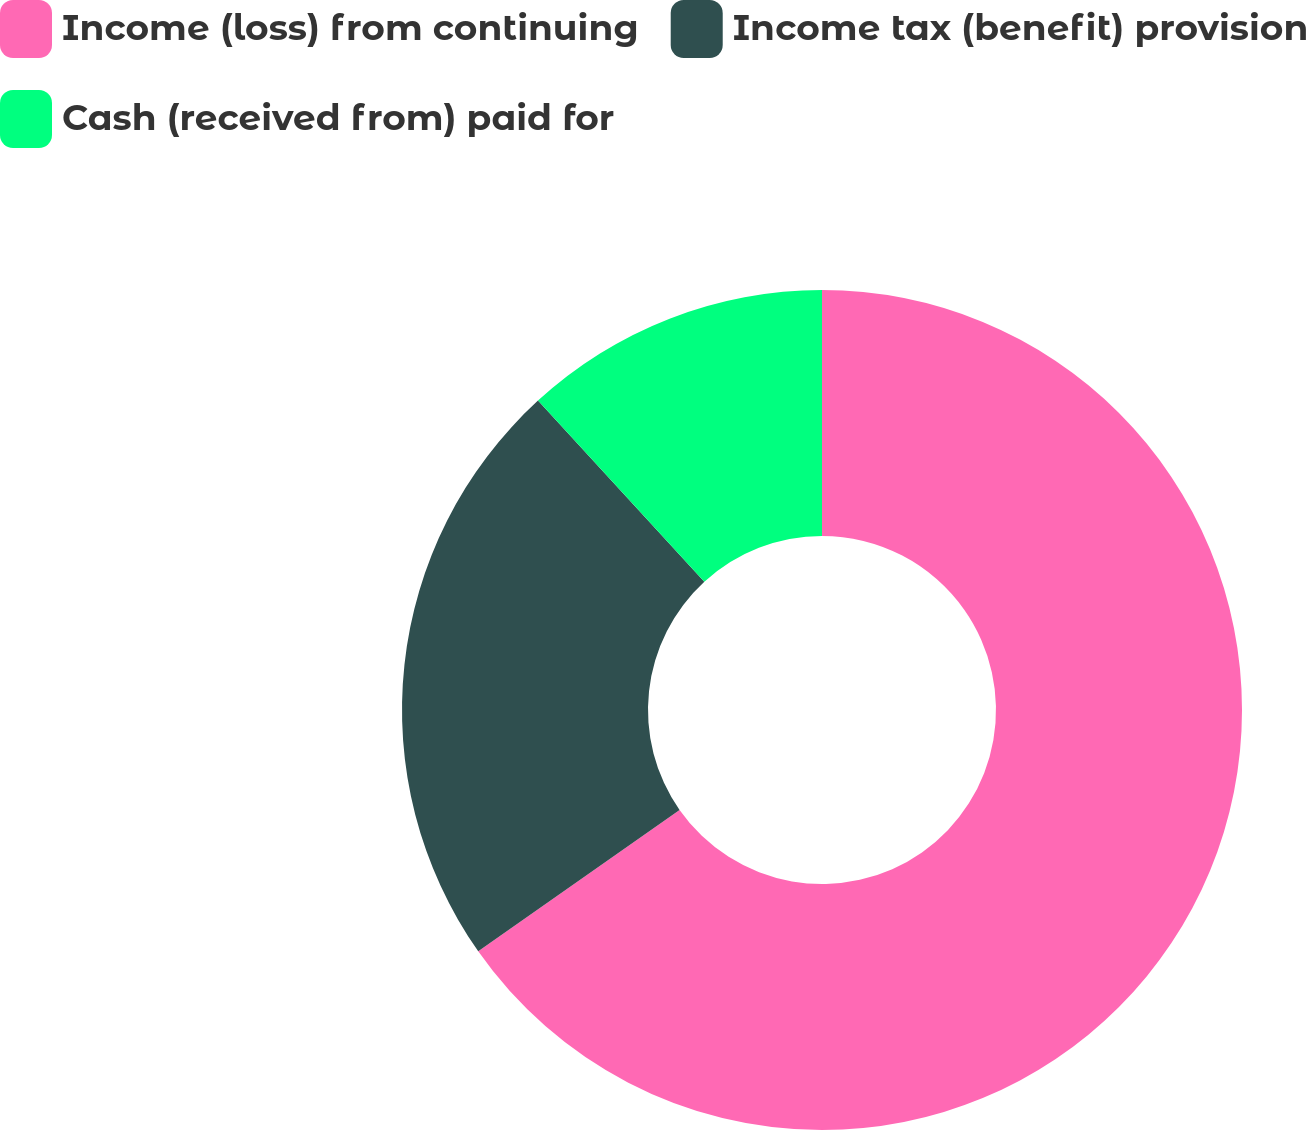<chart> <loc_0><loc_0><loc_500><loc_500><pie_chart><fcel>Income (loss) from continuing<fcel>Income tax (benefit) provision<fcel>Cash (received from) paid for<nl><fcel>65.26%<fcel>22.92%<fcel>11.82%<nl></chart> 